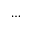Convert formula to latex. <formula><loc_0><loc_0><loc_500><loc_500>\dots</formula> 